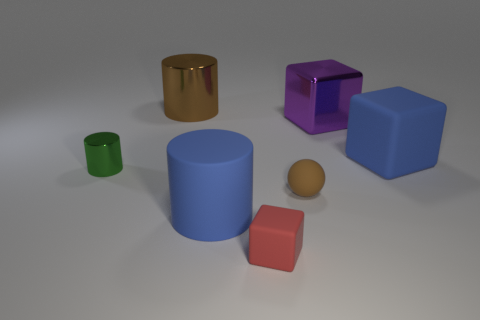How many matte things are cylinders or tiny red blocks?
Ensure brevity in your answer.  2. The brown shiny thing is what shape?
Offer a terse response. Cylinder. Are there any other things that are the same material as the brown ball?
Make the answer very short. Yes. Are the tiny red block and the tiny ball made of the same material?
Offer a very short reply. Yes. There is a big blue rubber thing in front of the blue object that is behind the matte cylinder; is there a tiny object left of it?
Provide a short and direct response. Yes. How many other things are there of the same shape as the brown metal object?
Keep it short and to the point. 2. What is the shape of the large object that is both in front of the big purple shiny cube and left of the small matte ball?
Give a very brief answer. Cylinder. There is a big matte thing that is right of the big cylinder in front of the big metallic thing right of the brown matte ball; what color is it?
Offer a very short reply. Blue. Are there more tiny matte objects behind the red cube than big metal cylinders on the left side of the small green metal object?
Give a very brief answer. Yes. How many other objects are there of the same size as the purple block?
Your response must be concise. 3. 